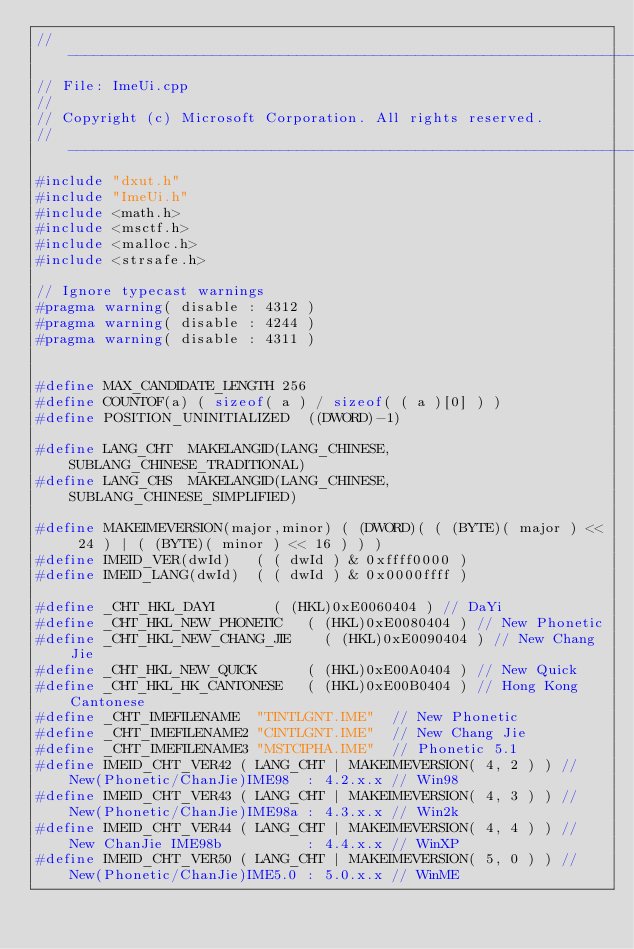Convert code to text. <code><loc_0><loc_0><loc_500><loc_500><_C++_>//--------------------------------------------------------------------------------------
// File: ImeUi.cpp
//
// Copyright (c) Microsoft Corporation. All rights reserved.
//--------------------------------------------------------------------------------------
#include "dxut.h"
#include "ImeUi.h"
#include <math.h>
#include <msctf.h>
#include <malloc.h>
#include <strsafe.h>

// Ignore typecast warnings
#pragma warning( disable : 4312 )
#pragma warning( disable : 4244 )
#pragma warning( disable : 4311 )


#define MAX_CANDIDATE_LENGTH 256
#define COUNTOF(a) ( sizeof( a ) / sizeof( ( a )[0] ) )
#define POSITION_UNINITIALIZED	((DWORD)-1)

#define LANG_CHT	MAKELANGID(LANG_CHINESE, SUBLANG_CHINESE_TRADITIONAL)
#define LANG_CHS	MAKELANGID(LANG_CHINESE, SUBLANG_CHINESE_SIMPLIFIED)

#define MAKEIMEVERSION(major,minor) ( (DWORD)( ( (BYTE)( major ) << 24 ) | ( (BYTE)( minor ) << 16 ) ) )
#define IMEID_VER(dwId)		( ( dwId ) & 0xffff0000 )
#define IMEID_LANG(dwId)	( ( dwId ) & 0x0000ffff )

#define _CHT_HKL_DAYI				( (HKL)0xE0060404 )	// DaYi
#define _CHT_HKL_NEW_PHONETIC		( (HKL)0xE0080404 )	// New Phonetic
#define _CHT_HKL_NEW_CHANG_JIE		( (HKL)0xE0090404 )	// New Chang Jie
#define _CHT_HKL_NEW_QUICK			( (HKL)0xE00A0404 )	// New Quick
#define _CHT_HKL_HK_CANTONESE		( (HKL)0xE00B0404 )	// Hong Kong Cantonese
#define _CHT_IMEFILENAME	"TINTLGNT.IME"	// New Phonetic
#define _CHT_IMEFILENAME2	"CINTLGNT.IME"	// New Chang Jie
#define _CHT_IMEFILENAME3	"MSTCIPHA.IME"	// Phonetic 5.1
#define IMEID_CHT_VER42 ( LANG_CHT | MAKEIMEVERSION( 4, 2 ) )	// New(Phonetic/ChanJie)IME98  : 4.2.x.x // Win98
#define IMEID_CHT_VER43 ( LANG_CHT | MAKEIMEVERSION( 4, 3 ) )	// New(Phonetic/ChanJie)IME98a : 4.3.x.x // Win2k
#define IMEID_CHT_VER44 ( LANG_CHT | MAKEIMEVERSION( 4, 4 ) )	// New ChanJie IME98b          : 4.4.x.x // WinXP
#define IMEID_CHT_VER50 ( LANG_CHT | MAKEIMEVERSION( 5, 0 ) )	// New(Phonetic/ChanJie)IME5.0 : 5.0.x.x // WinME</code> 